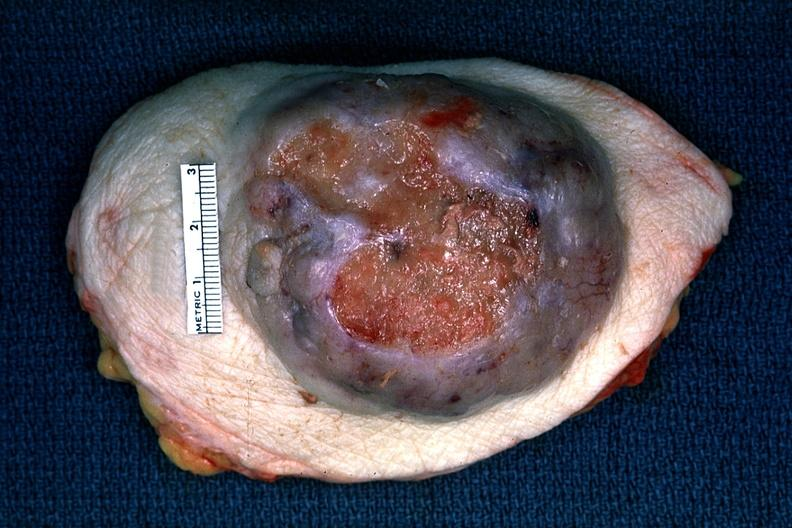where is this area in the body?
Answer the question using a single word or phrase. Breast 